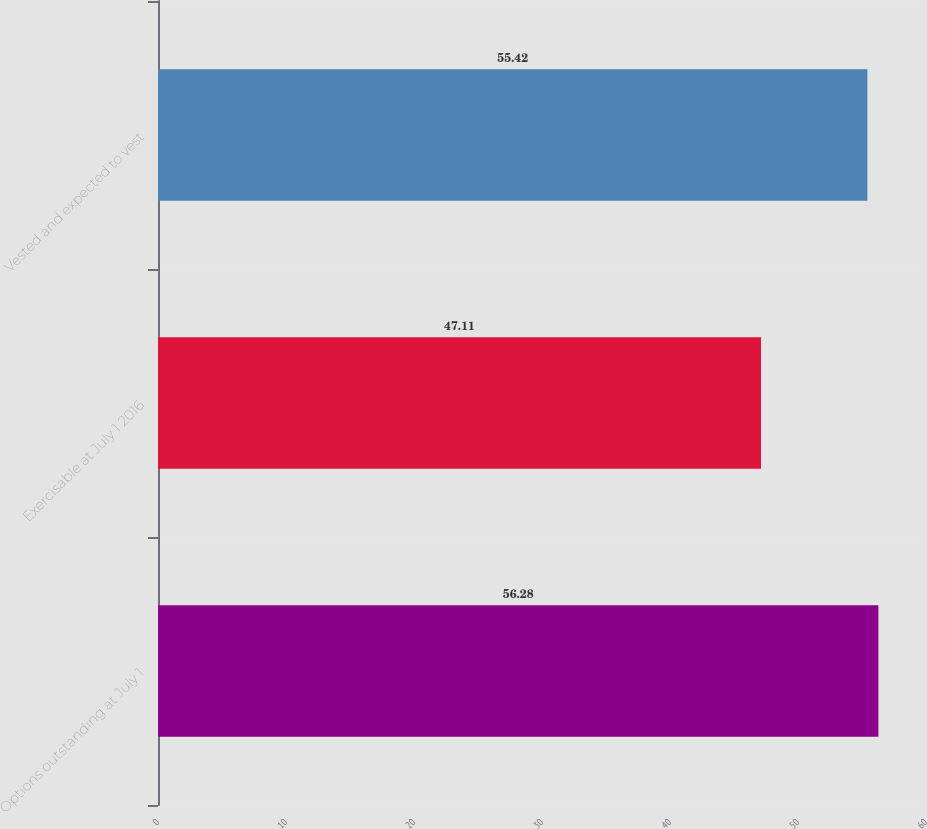<chart> <loc_0><loc_0><loc_500><loc_500><bar_chart><fcel>Options outstanding at July 1<fcel>Exercisable at July 1 2016<fcel>Vested and expected to vest<nl><fcel>56.28<fcel>47.11<fcel>55.42<nl></chart> 